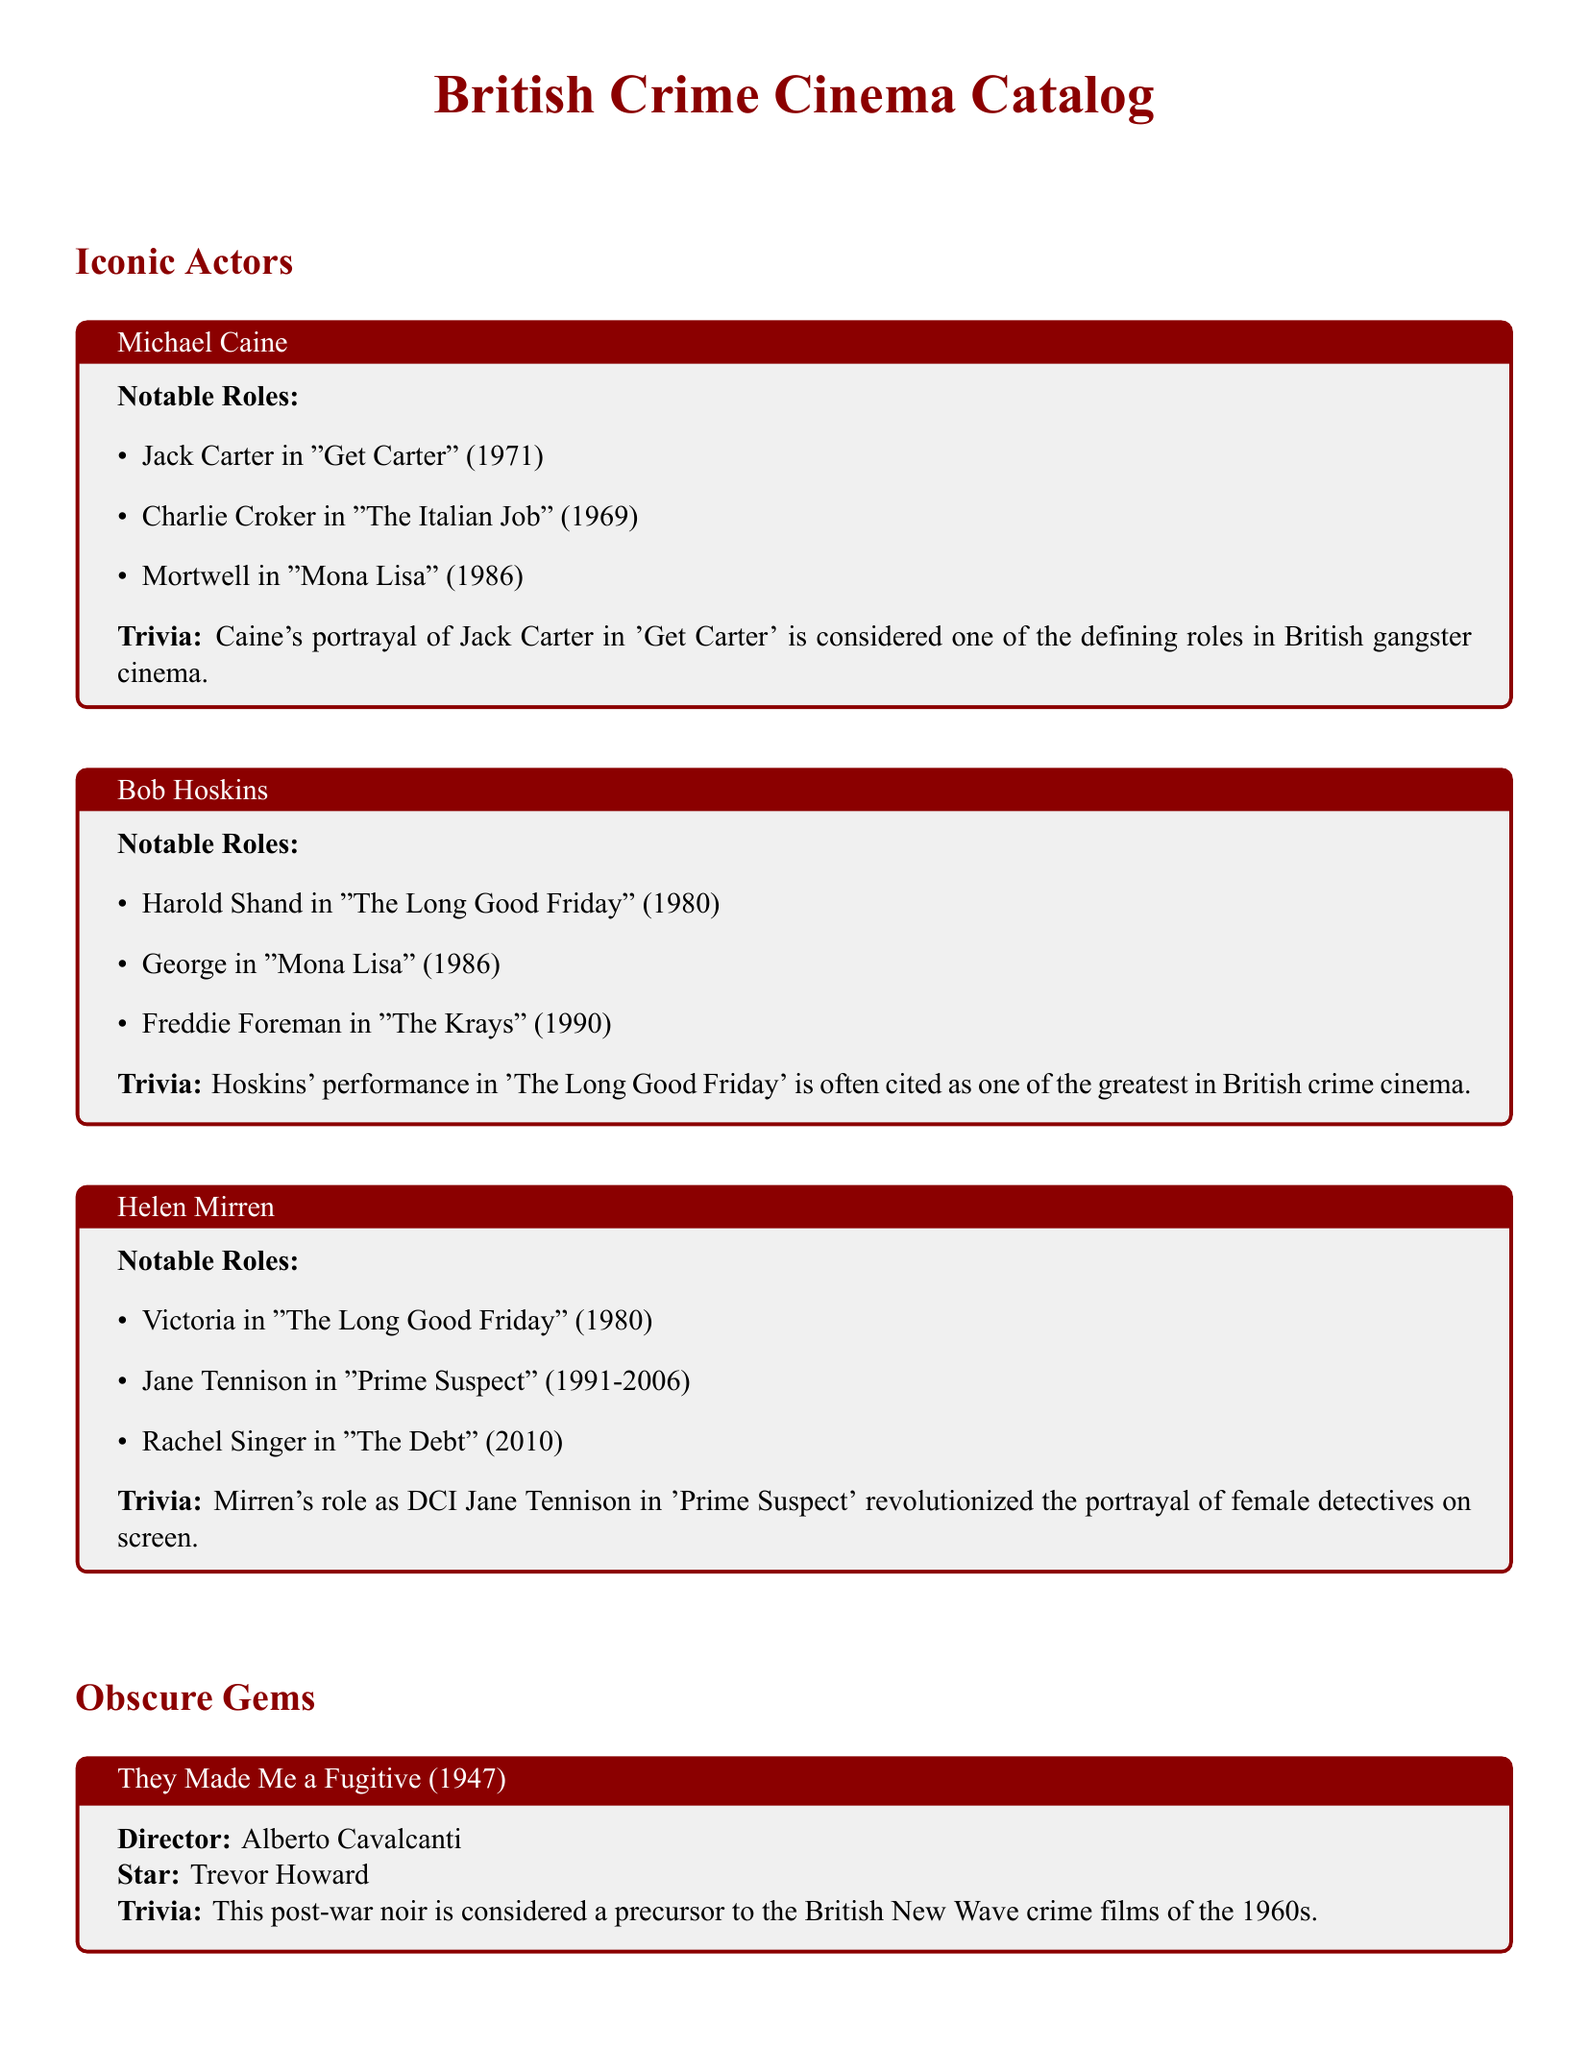What is the title of Michael Caine's role in "Get Carter"? Michael Caine's role in "Get Carter" is specifically mentioned in the document, which states he played Jack Carter.
Answer: Jack Carter Who directed "They Made Me a Fugitive"? The director of "They Made Me a Fugitive" is listed in the document, which states it was directed by Alberto Cavalcanti.
Answer: Alberto Cavalcanti In what year was "The Long Good Friday" released? "The Long Good Friday" is noted in the document with its release year, which is mentioned as 1980.
Answer: 1980 Which actor played the role of Victoria in "The Long Good Friday"? The document specifies that Helen Mirren played the role of Victoria in "The Long Good Friday."
Answer: Helen Mirren What is the main theme of "The Criminal"? The document provides a trivia section about "The Criminal" that notes it is recognized for its gritty realism, indicating its main theme.
Answer: Gritty realism Name one film influenced by "The Criminal." The document mentions that "The Criminal" influenced later British crime dramas, identifying it as a key film.
Answer: Later British crime dramas Which actor is associated with the film "Mona Lisa"? The document lists both Michael Caine and Bob Hoskins as actors with roles in "Mona Lisa," asking about actor associations.
Answer: Michael Caine and Bob Hoskins What notable role did Helen Mirren play in "Prime Suspect"? Helen Mirren's role in "Prime Suspect" is highlighted in the document, naming her character.
Answer: DCI Jane Tennison 